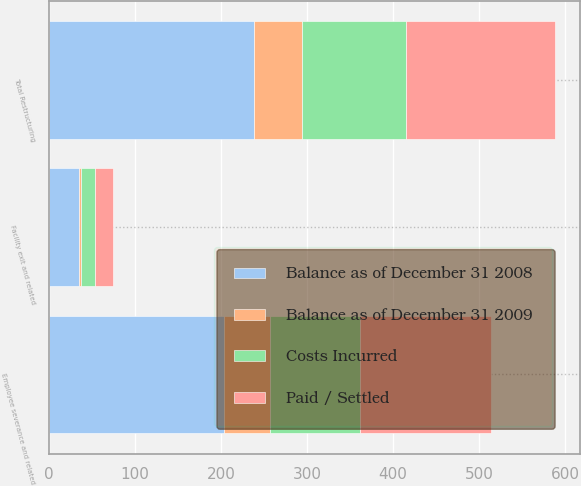Convert chart to OTSL. <chart><loc_0><loc_0><loc_500><loc_500><stacked_bar_chart><ecel><fcel>Employee severance and related<fcel>Facility exit and related<fcel>Total Restructuring<nl><fcel>Balance as of December 31 2009<fcel>52.7<fcel>2.6<fcel>55.3<nl><fcel>Balance as of December 31 2008<fcel>203.9<fcel>34.6<fcel>238.5<nl><fcel>Paid / Settled<fcel>151.6<fcel>20.6<fcel>172.2<nl><fcel>Costs Incurred<fcel>105<fcel>16.6<fcel>121.6<nl></chart> 